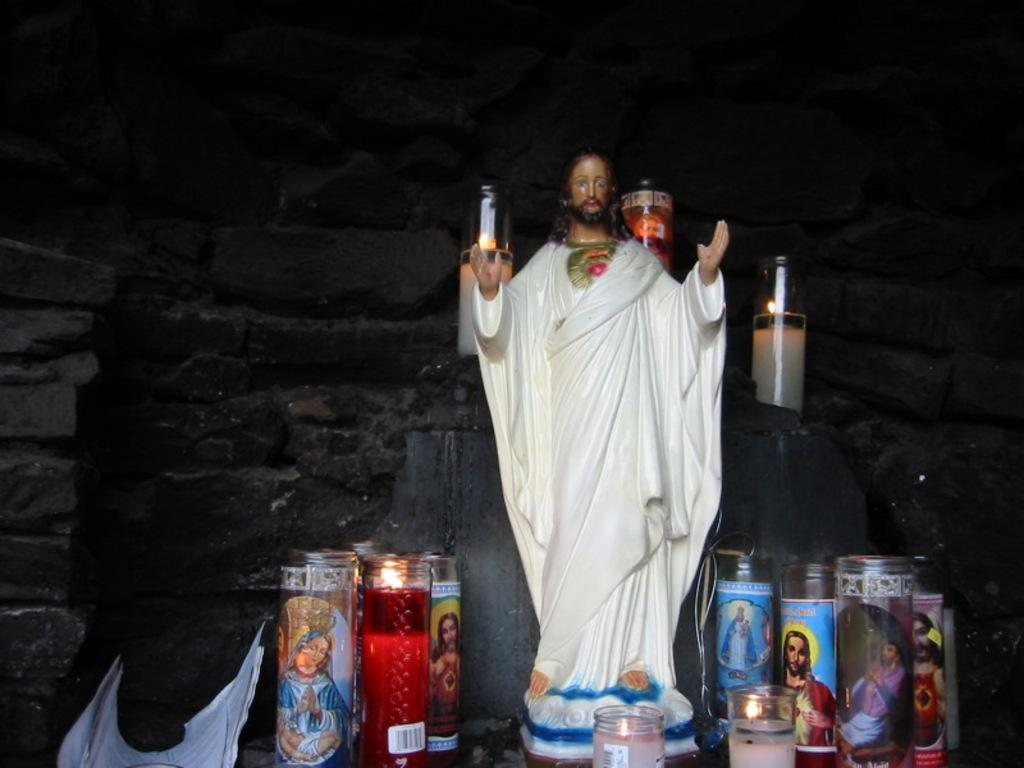What is the main subject of the image? There is a statue of Jesus in the image. What objects are present around the statue? There are candles in the image. What can be seen in the background of the image? There is a wall in the background of the image. What direction is the wind blowing in the image? There is no indication of wind in the image, so it cannot be determined. 